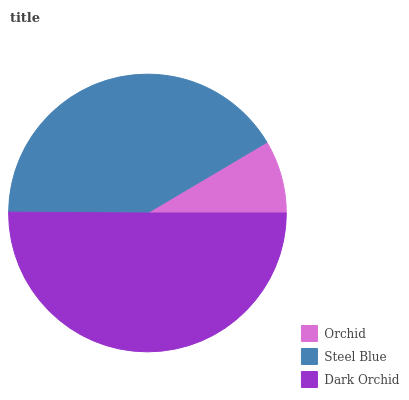Is Orchid the minimum?
Answer yes or no. Yes. Is Dark Orchid the maximum?
Answer yes or no. Yes. Is Steel Blue the minimum?
Answer yes or no. No. Is Steel Blue the maximum?
Answer yes or no. No. Is Steel Blue greater than Orchid?
Answer yes or no. Yes. Is Orchid less than Steel Blue?
Answer yes or no. Yes. Is Orchid greater than Steel Blue?
Answer yes or no. No. Is Steel Blue less than Orchid?
Answer yes or no. No. Is Steel Blue the high median?
Answer yes or no. Yes. Is Steel Blue the low median?
Answer yes or no. Yes. Is Dark Orchid the high median?
Answer yes or no. No. Is Orchid the low median?
Answer yes or no. No. 